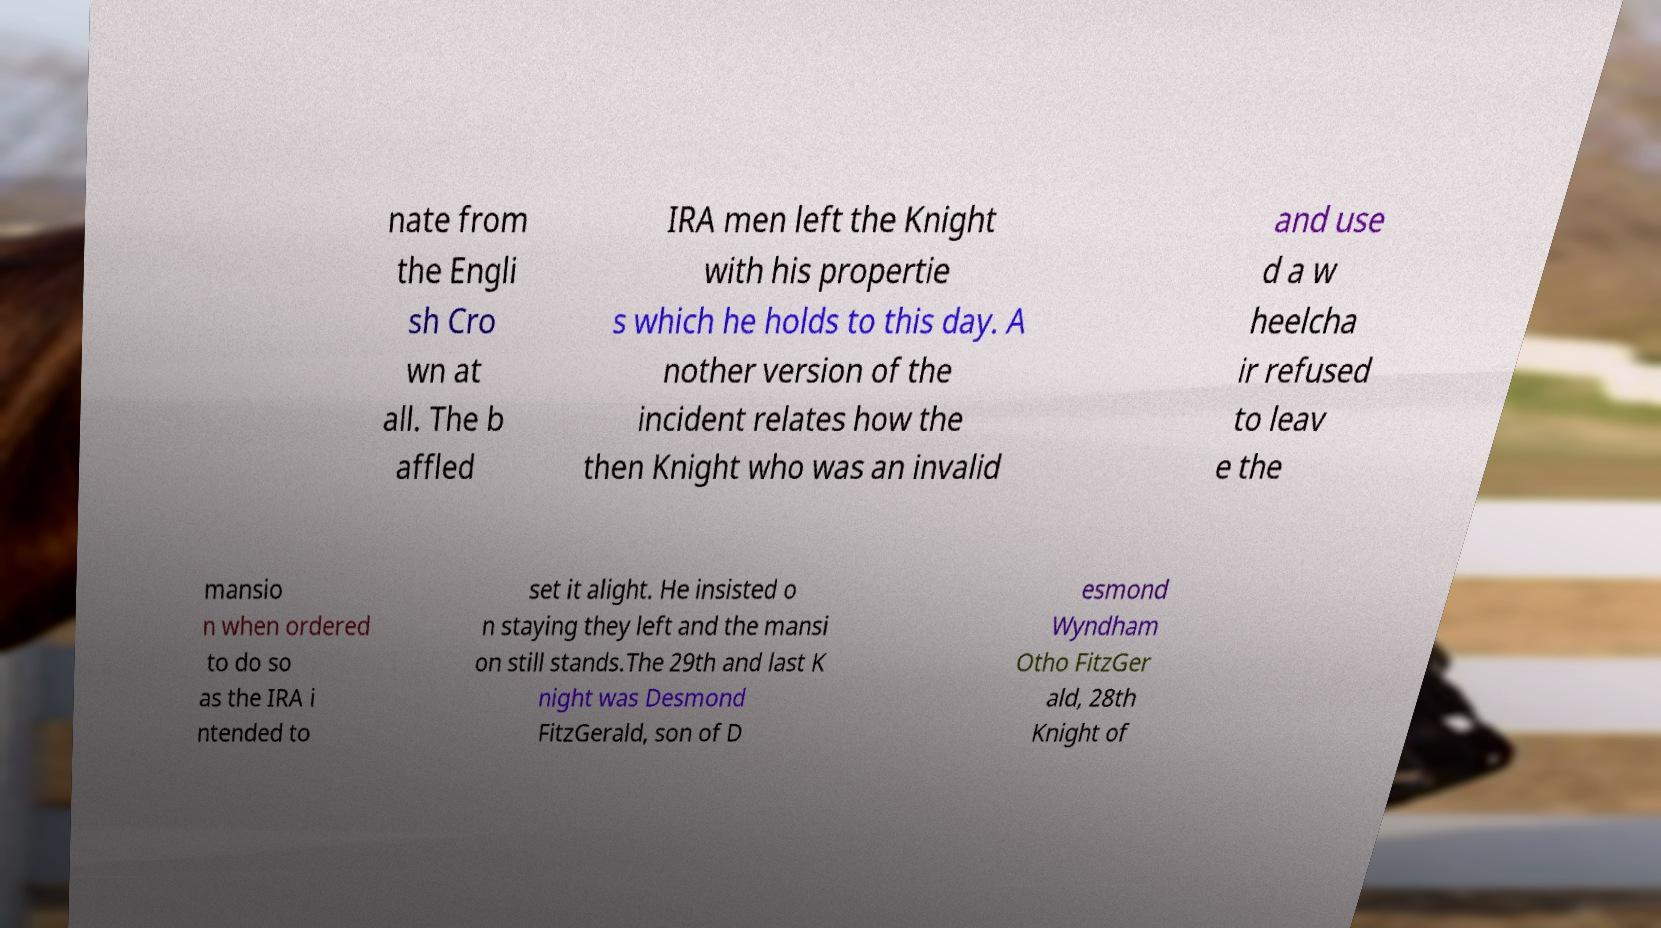What messages or text are displayed in this image? I need them in a readable, typed format. nate from the Engli sh Cro wn at all. The b affled IRA men left the Knight with his propertie s which he holds to this day. A nother version of the incident relates how the then Knight who was an invalid and use d a w heelcha ir refused to leav e the mansio n when ordered to do so as the IRA i ntended to set it alight. He insisted o n staying they left and the mansi on still stands.The 29th and last K night was Desmond FitzGerald, son of D esmond Wyndham Otho FitzGer ald, 28th Knight of 